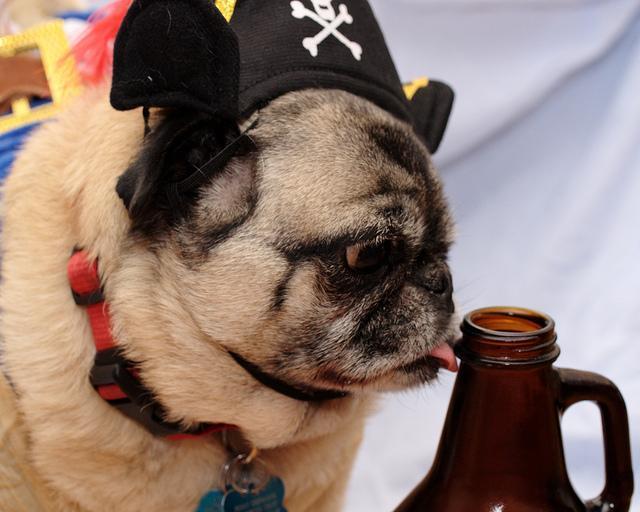How many of the train cars are yellow and red?
Give a very brief answer. 0. 